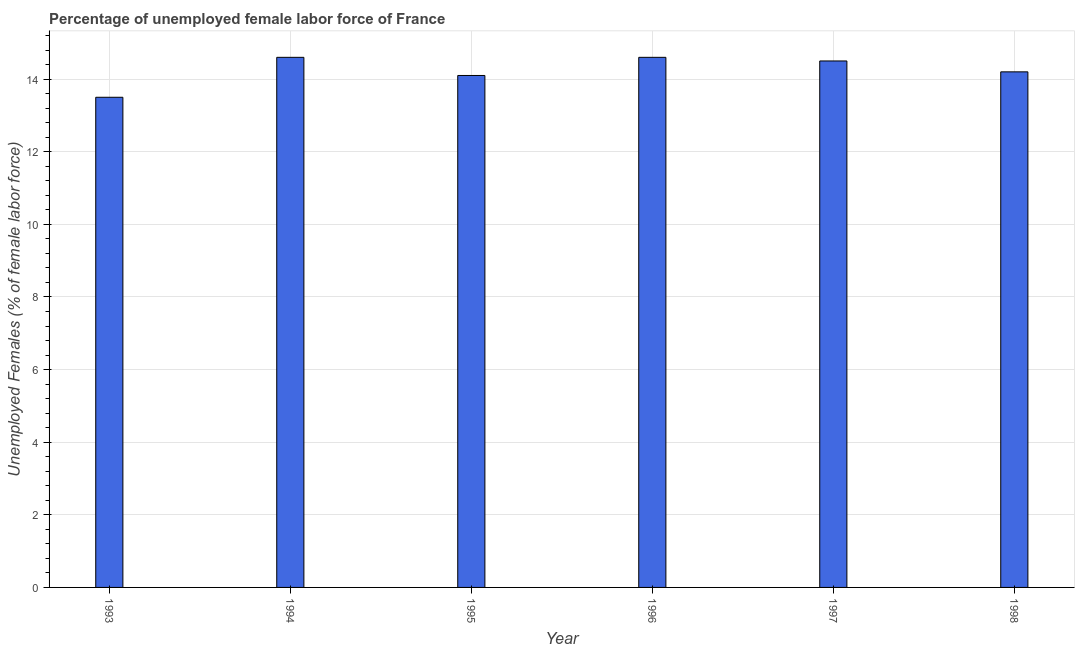Does the graph contain any zero values?
Offer a terse response. No. What is the title of the graph?
Provide a short and direct response. Percentage of unemployed female labor force of France. What is the label or title of the X-axis?
Your response must be concise. Year. What is the label or title of the Y-axis?
Provide a succinct answer. Unemployed Females (% of female labor force). Across all years, what is the maximum total unemployed female labour force?
Ensure brevity in your answer.  14.6. In which year was the total unemployed female labour force maximum?
Your answer should be compact. 1994. What is the sum of the total unemployed female labour force?
Your answer should be very brief. 85.5. What is the average total unemployed female labour force per year?
Provide a succinct answer. 14.25. What is the median total unemployed female labour force?
Make the answer very short. 14.35. In how many years, is the total unemployed female labour force greater than 7.2 %?
Your response must be concise. 6. Do a majority of the years between 1995 and 1994 (inclusive) have total unemployed female labour force greater than 10.8 %?
Make the answer very short. No. What is the ratio of the total unemployed female labour force in 1994 to that in 1995?
Make the answer very short. 1.03. Is the difference between the total unemployed female labour force in 1996 and 1998 greater than the difference between any two years?
Your response must be concise. No. What is the difference between the highest and the second highest total unemployed female labour force?
Give a very brief answer. 0. In how many years, is the total unemployed female labour force greater than the average total unemployed female labour force taken over all years?
Make the answer very short. 3. How many bars are there?
Make the answer very short. 6. Are the values on the major ticks of Y-axis written in scientific E-notation?
Give a very brief answer. No. What is the Unemployed Females (% of female labor force) in 1993?
Ensure brevity in your answer.  13.5. What is the Unemployed Females (% of female labor force) in 1994?
Your answer should be very brief. 14.6. What is the Unemployed Females (% of female labor force) in 1995?
Your response must be concise. 14.1. What is the Unemployed Females (% of female labor force) of 1996?
Offer a terse response. 14.6. What is the Unemployed Females (% of female labor force) of 1997?
Your response must be concise. 14.5. What is the Unemployed Females (% of female labor force) of 1998?
Ensure brevity in your answer.  14.2. What is the difference between the Unemployed Females (% of female labor force) in 1993 and 1994?
Offer a very short reply. -1.1. What is the difference between the Unemployed Females (% of female labor force) in 1993 and 1997?
Offer a terse response. -1. What is the difference between the Unemployed Females (% of female labor force) in 1994 and 1996?
Make the answer very short. 0. What is the difference between the Unemployed Females (% of female labor force) in 1994 and 1997?
Provide a succinct answer. 0.1. What is the difference between the Unemployed Females (% of female labor force) in 1996 and 1997?
Keep it short and to the point. 0.1. What is the difference between the Unemployed Females (% of female labor force) in 1996 and 1998?
Your answer should be compact. 0.4. What is the ratio of the Unemployed Females (% of female labor force) in 1993 to that in 1994?
Provide a succinct answer. 0.93. What is the ratio of the Unemployed Females (% of female labor force) in 1993 to that in 1996?
Provide a short and direct response. 0.93. What is the ratio of the Unemployed Females (% of female labor force) in 1993 to that in 1998?
Your response must be concise. 0.95. What is the ratio of the Unemployed Females (% of female labor force) in 1994 to that in 1995?
Offer a very short reply. 1.03. What is the ratio of the Unemployed Females (% of female labor force) in 1994 to that in 1996?
Your answer should be very brief. 1. What is the ratio of the Unemployed Females (% of female labor force) in 1994 to that in 1998?
Offer a terse response. 1.03. What is the ratio of the Unemployed Females (% of female labor force) in 1995 to that in 1996?
Make the answer very short. 0.97. What is the ratio of the Unemployed Females (% of female labor force) in 1995 to that in 1997?
Give a very brief answer. 0.97. What is the ratio of the Unemployed Females (% of female labor force) in 1996 to that in 1997?
Provide a short and direct response. 1.01. What is the ratio of the Unemployed Females (% of female labor force) in 1996 to that in 1998?
Your response must be concise. 1.03. What is the ratio of the Unemployed Females (% of female labor force) in 1997 to that in 1998?
Your answer should be compact. 1.02. 